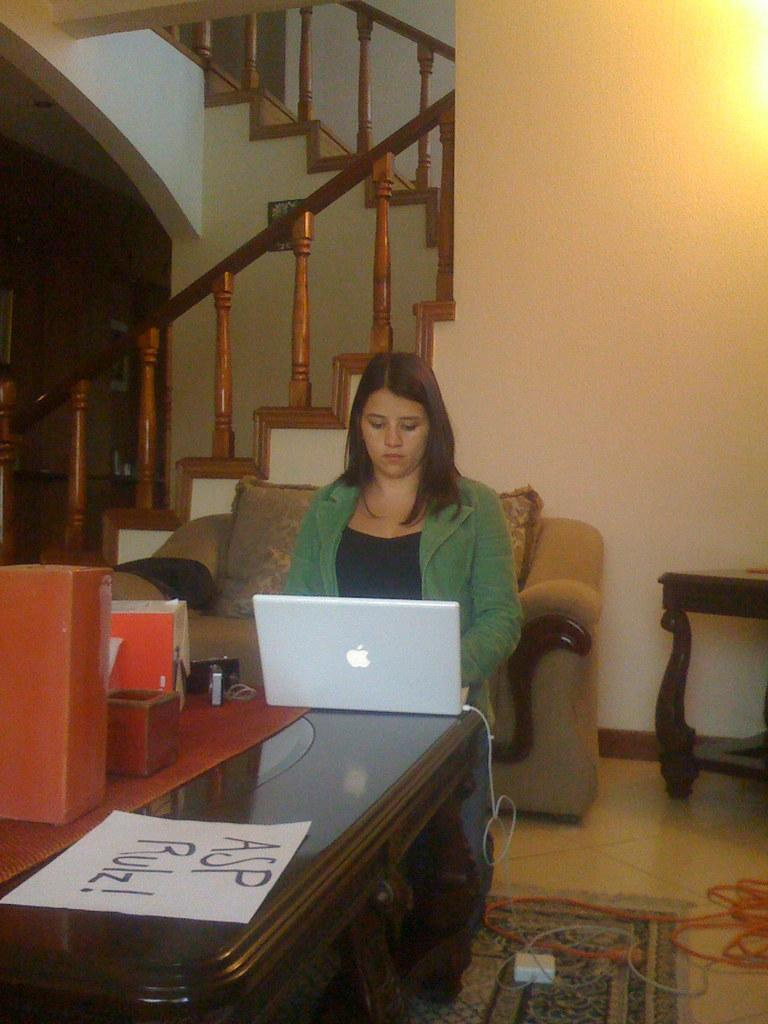What is the person in the image doing? The person is sitting on a chair. What object is on the table in front of the person? There is a laptop on the table. What else can be seen on the table? There is a box and paper on the table. What can be seen in the background of the image? There is a wall and staircases in the background. What floor level is the person on? This is a floor (assuming the context refers to the floor level). How does the person maintain their balance while sitting on the chair? The person does not need to maintain their balance while sitting on the chair, as it is a stable object. 